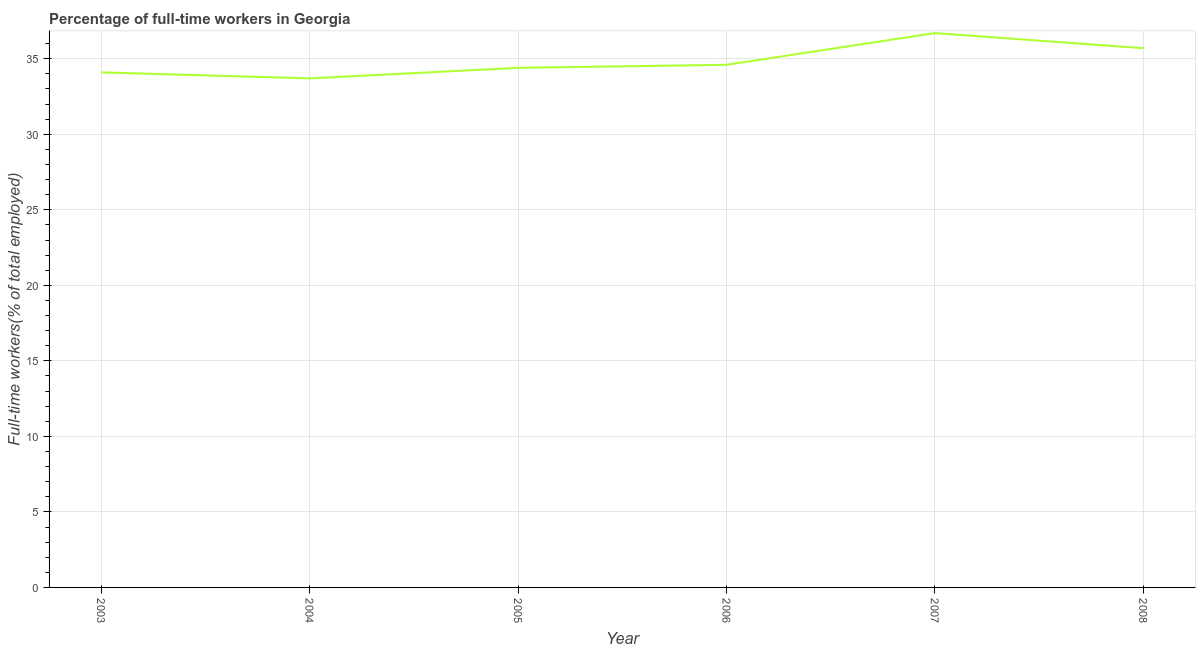What is the percentage of full-time workers in 2008?
Make the answer very short. 35.7. Across all years, what is the maximum percentage of full-time workers?
Your answer should be compact. 36.7. Across all years, what is the minimum percentage of full-time workers?
Keep it short and to the point. 33.7. In which year was the percentage of full-time workers minimum?
Provide a short and direct response. 2004. What is the sum of the percentage of full-time workers?
Provide a short and direct response. 209.2. What is the difference between the percentage of full-time workers in 2006 and 2008?
Make the answer very short. -1.1. What is the average percentage of full-time workers per year?
Ensure brevity in your answer.  34.87. What is the median percentage of full-time workers?
Provide a short and direct response. 34.5. In how many years, is the percentage of full-time workers greater than 3 %?
Keep it short and to the point. 6. Do a majority of the years between 2004 and 2008 (inclusive) have percentage of full-time workers greater than 13 %?
Provide a succinct answer. Yes. What is the ratio of the percentage of full-time workers in 2004 to that in 2005?
Offer a very short reply. 0.98. What is the difference between the highest and the second highest percentage of full-time workers?
Your answer should be compact. 1. Is the sum of the percentage of full-time workers in 2003 and 2005 greater than the maximum percentage of full-time workers across all years?
Keep it short and to the point. Yes. In how many years, is the percentage of full-time workers greater than the average percentage of full-time workers taken over all years?
Your answer should be very brief. 2. What is the difference between two consecutive major ticks on the Y-axis?
Provide a short and direct response. 5. Are the values on the major ticks of Y-axis written in scientific E-notation?
Make the answer very short. No. Does the graph contain any zero values?
Offer a terse response. No. What is the title of the graph?
Provide a short and direct response. Percentage of full-time workers in Georgia. What is the label or title of the Y-axis?
Your answer should be very brief. Full-time workers(% of total employed). What is the Full-time workers(% of total employed) of 2003?
Keep it short and to the point. 34.1. What is the Full-time workers(% of total employed) of 2004?
Offer a very short reply. 33.7. What is the Full-time workers(% of total employed) in 2005?
Your response must be concise. 34.4. What is the Full-time workers(% of total employed) of 2006?
Give a very brief answer. 34.6. What is the Full-time workers(% of total employed) in 2007?
Provide a short and direct response. 36.7. What is the Full-time workers(% of total employed) of 2008?
Make the answer very short. 35.7. What is the difference between the Full-time workers(% of total employed) in 2003 and 2004?
Provide a succinct answer. 0.4. What is the difference between the Full-time workers(% of total employed) in 2003 and 2008?
Provide a succinct answer. -1.6. What is the difference between the Full-time workers(% of total employed) in 2004 and 2005?
Provide a succinct answer. -0.7. What is the difference between the Full-time workers(% of total employed) in 2005 and 2006?
Offer a terse response. -0.2. What is the difference between the Full-time workers(% of total employed) in 2005 and 2008?
Ensure brevity in your answer.  -1.3. What is the difference between the Full-time workers(% of total employed) in 2006 and 2008?
Provide a short and direct response. -1.1. What is the ratio of the Full-time workers(% of total employed) in 2003 to that in 2006?
Provide a short and direct response. 0.99. What is the ratio of the Full-time workers(% of total employed) in 2003 to that in 2007?
Your answer should be very brief. 0.93. What is the ratio of the Full-time workers(% of total employed) in 2003 to that in 2008?
Your response must be concise. 0.95. What is the ratio of the Full-time workers(% of total employed) in 2004 to that in 2006?
Your answer should be compact. 0.97. What is the ratio of the Full-time workers(% of total employed) in 2004 to that in 2007?
Your answer should be very brief. 0.92. What is the ratio of the Full-time workers(% of total employed) in 2004 to that in 2008?
Your answer should be very brief. 0.94. What is the ratio of the Full-time workers(% of total employed) in 2005 to that in 2006?
Provide a succinct answer. 0.99. What is the ratio of the Full-time workers(% of total employed) in 2005 to that in 2007?
Offer a very short reply. 0.94. What is the ratio of the Full-time workers(% of total employed) in 2006 to that in 2007?
Your response must be concise. 0.94. What is the ratio of the Full-time workers(% of total employed) in 2006 to that in 2008?
Your answer should be compact. 0.97. What is the ratio of the Full-time workers(% of total employed) in 2007 to that in 2008?
Your answer should be compact. 1.03. 